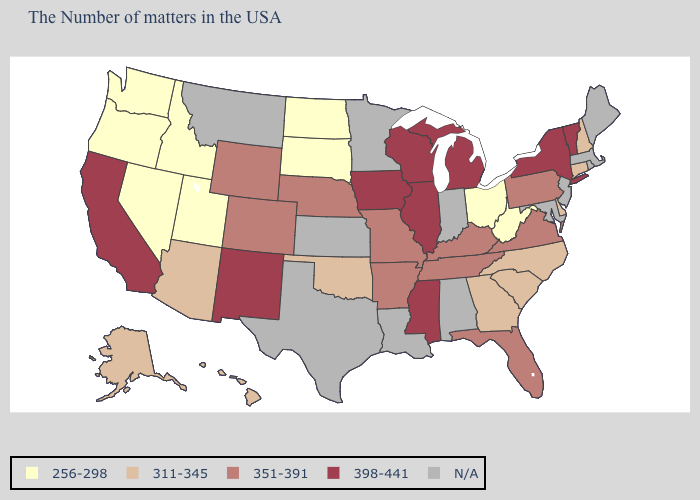What is the lowest value in the South?
Answer briefly. 256-298. What is the value of Maine?
Concise answer only. N/A. What is the value of Colorado?
Quick response, please. 351-391. Name the states that have a value in the range 256-298?
Answer briefly. West Virginia, Ohio, South Dakota, North Dakota, Utah, Idaho, Nevada, Washington, Oregon. Which states have the highest value in the USA?
Concise answer only. Vermont, New York, Michigan, Wisconsin, Illinois, Mississippi, Iowa, New Mexico, California. What is the value of Kentucky?
Keep it brief. 351-391. What is the value of Arizona?
Write a very short answer. 311-345. Does the first symbol in the legend represent the smallest category?
Short answer required. Yes. Which states have the lowest value in the Northeast?
Answer briefly. New Hampshire, Connecticut. What is the lowest value in states that border North Dakota?
Answer briefly. 256-298. Does the map have missing data?
Answer briefly. Yes. Which states hav the highest value in the West?
Concise answer only. New Mexico, California. What is the value of West Virginia?
Write a very short answer. 256-298. What is the highest value in states that border Idaho?
Keep it brief. 351-391. 